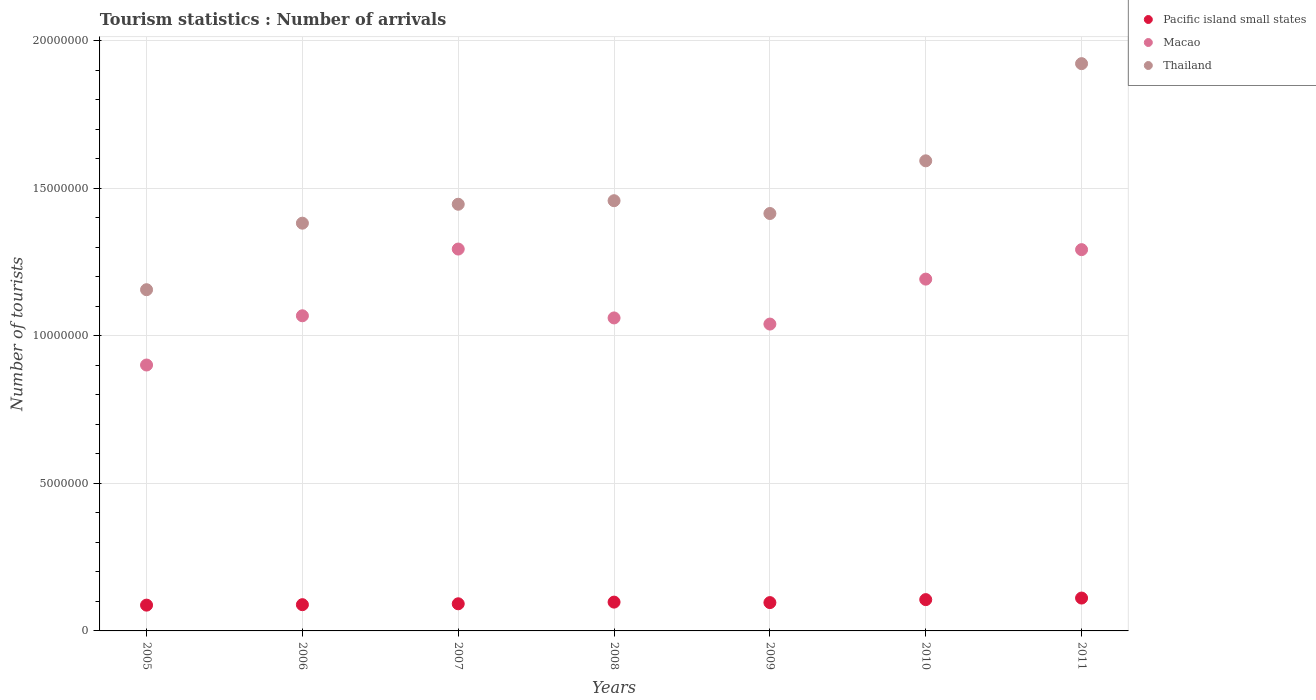Is the number of dotlines equal to the number of legend labels?
Your answer should be compact. Yes. What is the number of tourist arrivals in Macao in 2011?
Your answer should be very brief. 1.29e+07. Across all years, what is the maximum number of tourist arrivals in Pacific island small states?
Make the answer very short. 1.11e+06. Across all years, what is the minimum number of tourist arrivals in Macao?
Offer a terse response. 9.01e+06. In which year was the number of tourist arrivals in Thailand maximum?
Your response must be concise. 2011. What is the total number of tourist arrivals in Pacific island small states in the graph?
Provide a succinct answer. 6.79e+06. What is the difference between the number of tourist arrivals in Pacific island small states in 2005 and that in 2011?
Provide a short and direct response. -2.40e+05. What is the difference between the number of tourist arrivals in Thailand in 2009 and the number of tourist arrivals in Macao in 2010?
Provide a short and direct response. 2.22e+06. What is the average number of tourist arrivals in Thailand per year?
Provide a short and direct response. 1.48e+07. In the year 2010, what is the difference between the number of tourist arrivals in Pacific island small states and number of tourist arrivals in Macao?
Offer a very short reply. -1.09e+07. What is the ratio of the number of tourist arrivals in Pacific island small states in 2007 to that in 2009?
Ensure brevity in your answer.  0.96. Is the number of tourist arrivals in Pacific island small states in 2005 less than that in 2010?
Ensure brevity in your answer.  Yes. What is the difference between the highest and the lowest number of tourist arrivals in Macao?
Provide a short and direct response. 3.93e+06. In how many years, is the number of tourist arrivals in Macao greater than the average number of tourist arrivals in Macao taken over all years?
Give a very brief answer. 3. Is the number of tourist arrivals in Thailand strictly greater than the number of tourist arrivals in Macao over the years?
Your response must be concise. Yes. Is the number of tourist arrivals in Thailand strictly less than the number of tourist arrivals in Macao over the years?
Keep it short and to the point. No. What is the difference between two consecutive major ticks on the Y-axis?
Offer a terse response. 5.00e+06. Does the graph contain any zero values?
Your response must be concise. No. Where does the legend appear in the graph?
Keep it short and to the point. Top right. What is the title of the graph?
Your answer should be compact. Tourism statistics : Number of arrivals. What is the label or title of the X-axis?
Your answer should be very brief. Years. What is the label or title of the Y-axis?
Offer a terse response. Number of tourists. What is the Number of tourists in Pacific island small states in 2005?
Provide a short and direct response. 8.74e+05. What is the Number of tourists in Macao in 2005?
Provide a short and direct response. 9.01e+06. What is the Number of tourists in Thailand in 2005?
Offer a very short reply. 1.16e+07. What is the Number of tourists in Pacific island small states in 2006?
Your response must be concise. 8.90e+05. What is the Number of tourists in Macao in 2006?
Keep it short and to the point. 1.07e+07. What is the Number of tourists in Thailand in 2006?
Give a very brief answer. 1.38e+07. What is the Number of tourists in Pacific island small states in 2007?
Give a very brief answer. 9.20e+05. What is the Number of tourists in Macao in 2007?
Keep it short and to the point. 1.29e+07. What is the Number of tourists in Thailand in 2007?
Keep it short and to the point. 1.45e+07. What is the Number of tourists of Pacific island small states in 2008?
Make the answer very short. 9.77e+05. What is the Number of tourists of Macao in 2008?
Make the answer very short. 1.06e+07. What is the Number of tourists of Thailand in 2008?
Offer a terse response. 1.46e+07. What is the Number of tourists of Pacific island small states in 2009?
Give a very brief answer. 9.60e+05. What is the Number of tourists of Macao in 2009?
Offer a terse response. 1.04e+07. What is the Number of tourists of Thailand in 2009?
Offer a very short reply. 1.42e+07. What is the Number of tourists in Pacific island small states in 2010?
Offer a very short reply. 1.06e+06. What is the Number of tourists of Macao in 2010?
Offer a very short reply. 1.19e+07. What is the Number of tourists of Thailand in 2010?
Keep it short and to the point. 1.59e+07. What is the Number of tourists in Pacific island small states in 2011?
Provide a short and direct response. 1.11e+06. What is the Number of tourists of Macao in 2011?
Ensure brevity in your answer.  1.29e+07. What is the Number of tourists of Thailand in 2011?
Your response must be concise. 1.92e+07. Across all years, what is the maximum Number of tourists in Pacific island small states?
Offer a terse response. 1.11e+06. Across all years, what is the maximum Number of tourists of Macao?
Your response must be concise. 1.29e+07. Across all years, what is the maximum Number of tourists in Thailand?
Your response must be concise. 1.92e+07. Across all years, what is the minimum Number of tourists in Pacific island small states?
Make the answer very short. 8.74e+05. Across all years, what is the minimum Number of tourists in Macao?
Offer a very short reply. 9.01e+06. Across all years, what is the minimum Number of tourists of Thailand?
Give a very brief answer. 1.16e+07. What is the total Number of tourists of Pacific island small states in the graph?
Give a very brief answer. 6.79e+06. What is the total Number of tourists in Macao in the graph?
Keep it short and to the point. 7.85e+07. What is the total Number of tourists in Thailand in the graph?
Offer a terse response. 1.04e+08. What is the difference between the Number of tourists of Pacific island small states in 2005 and that in 2006?
Your answer should be compact. -1.53e+04. What is the difference between the Number of tourists in Macao in 2005 and that in 2006?
Your response must be concise. -1.67e+06. What is the difference between the Number of tourists of Thailand in 2005 and that in 2006?
Offer a terse response. -2.26e+06. What is the difference between the Number of tourists in Pacific island small states in 2005 and that in 2007?
Give a very brief answer. -4.56e+04. What is the difference between the Number of tourists in Macao in 2005 and that in 2007?
Your answer should be very brief. -3.93e+06. What is the difference between the Number of tourists in Thailand in 2005 and that in 2007?
Make the answer very short. -2.90e+06. What is the difference between the Number of tourists in Pacific island small states in 2005 and that in 2008?
Provide a succinct answer. -1.02e+05. What is the difference between the Number of tourists of Macao in 2005 and that in 2008?
Provide a short and direct response. -1.60e+06. What is the difference between the Number of tourists in Thailand in 2005 and that in 2008?
Give a very brief answer. -3.02e+06. What is the difference between the Number of tourists in Pacific island small states in 2005 and that in 2009?
Make the answer very short. -8.60e+04. What is the difference between the Number of tourists in Macao in 2005 and that in 2009?
Keep it short and to the point. -1.39e+06. What is the difference between the Number of tourists in Thailand in 2005 and that in 2009?
Your answer should be compact. -2.58e+06. What is the difference between the Number of tourists in Pacific island small states in 2005 and that in 2010?
Ensure brevity in your answer.  -1.86e+05. What is the difference between the Number of tourists of Macao in 2005 and that in 2010?
Provide a succinct answer. -2.91e+06. What is the difference between the Number of tourists of Thailand in 2005 and that in 2010?
Give a very brief answer. -4.37e+06. What is the difference between the Number of tourists in Pacific island small states in 2005 and that in 2011?
Your response must be concise. -2.40e+05. What is the difference between the Number of tourists in Macao in 2005 and that in 2011?
Make the answer very short. -3.91e+06. What is the difference between the Number of tourists in Thailand in 2005 and that in 2011?
Make the answer very short. -7.66e+06. What is the difference between the Number of tourists in Pacific island small states in 2006 and that in 2007?
Keep it short and to the point. -3.03e+04. What is the difference between the Number of tourists in Macao in 2006 and that in 2007?
Ensure brevity in your answer.  -2.26e+06. What is the difference between the Number of tourists of Thailand in 2006 and that in 2007?
Make the answer very short. -6.42e+05. What is the difference between the Number of tourists in Pacific island small states in 2006 and that in 2008?
Provide a short and direct response. -8.71e+04. What is the difference between the Number of tourists in Macao in 2006 and that in 2008?
Provide a short and direct response. 7.30e+04. What is the difference between the Number of tourists in Thailand in 2006 and that in 2008?
Keep it short and to the point. -7.62e+05. What is the difference between the Number of tourists in Pacific island small states in 2006 and that in 2009?
Ensure brevity in your answer.  -7.07e+04. What is the difference between the Number of tourists of Macao in 2006 and that in 2009?
Offer a very short reply. 2.81e+05. What is the difference between the Number of tourists in Thailand in 2006 and that in 2009?
Offer a very short reply. -3.28e+05. What is the difference between the Number of tourists in Pacific island small states in 2006 and that in 2010?
Your answer should be very brief. -1.71e+05. What is the difference between the Number of tourists of Macao in 2006 and that in 2010?
Your answer should be compact. -1.24e+06. What is the difference between the Number of tourists in Thailand in 2006 and that in 2010?
Your answer should be very brief. -2.11e+06. What is the difference between the Number of tourists of Pacific island small states in 2006 and that in 2011?
Offer a very short reply. -2.24e+05. What is the difference between the Number of tourists of Macao in 2006 and that in 2011?
Your answer should be very brief. -2.24e+06. What is the difference between the Number of tourists of Thailand in 2006 and that in 2011?
Provide a succinct answer. -5.41e+06. What is the difference between the Number of tourists of Pacific island small states in 2007 and that in 2008?
Your answer should be very brief. -5.68e+04. What is the difference between the Number of tourists in Macao in 2007 and that in 2008?
Offer a terse response. 2.34e+06. What is the difference between the Number of tourists in Pacific island small states in 2007 and that in 2009?
Give a very brief answer. -4.04e+04. What is the difference between the Number of tourists in Macao in 2007 and that in 2009?
Ensure brevity in your answer.  2.54e+06. What is the difference between the Number of tourists in Thailand in 2007 and that in 2009?
Your response must be concise. 3.14e+05. What is the difference between the Number of tourists of Pacific island small states in 2007 and that in 2010?
Ensure brevity in your answer.  -1.41e+05. What is the difference between the Number of tourists in Macao in 2007 and that in 2010?
Ensure brevity in your answer.  1.02e+06. What is the difference between the Number of tourists of Thailand in 2007 and that in 2010?
Offer a terse response. -1.47e+06. What is the difference between the Number of tourists of Pacific island small states in 2007 and that in 2011?
Your answer should be very brief. -1.94e+05. What is the difference between the Number of tourists in Macao in 2007 and that in 2011?
Ensure brevity in your answer.  2.00e+04. What is the difference between the Number of tourists in Thailand in 2007 and that in 2011?
Provide a short and direct response. -4.77e+06. What is the difference between the Number of tourists of Pacific island small states in 2008 and that in 2009?
Offer a very short reply. 1.64e+04. What is the difference between the Number of tourists in Macao in 2008 and that in 2009?
Offer a terse response. 2.08e+05. What is the difference between the Number of tourists of Thailand in 2008 and that in 2009?
Make the answer very short. 4.34e+05. What is the difference between the Number of tourists of Pacific island small states in 2008 and that in 2010?
Your response must be concise. -8.39e+04. What is the difference between the Number of tourists of Macao in 2008 and that in 2010?
Provide a short and direct response. -1.32e+06. What is the difference between the Number of tourists in Thailand in 2008 and that in 2010?
Ensure brevity in your answer.  -1.35e+06. What is the difference between the Number of tourists in Pacific island small states in 2008 and that in 2011?
Give a very brief answer. -1.37e+05. What is the difference between the Number of tourists of Macao in 2008 and that in 2011?
Give a very brief answer. -2.32e+06. What is the difference between the Number of tourists in Thailand in 2008 and that in 2011?
Offer a terse response. -4.65e+06. What is the difference between the Number of tourists in Pacific island small states in 2009 and that in 2010?
Your response must be concise. -1.00e+05. What is the difference between the Number of tourists of Macao in 2009 and that in 2010?
Keep it short and to the point. -1.52e+06. What is the difference between the Number of tourists of Thailand in 2009 and that in 2010?
Your response must be concise. -1.79e+06. What is the difference between the Number of tourists of Pacific island small states in 2009 and that in 2011?
Offer a terse response. -1.54e+05. What is the difference between the Number of tourists of Macao in 2009 and that in 2011?
Offer a very short reply. -2.52e+06. What is the difference between the Number of tourists of Thailand in 2009 and that in 2011?
Offer a very short reply. -5.08e+06. What is the difference between the Number of tourists of Pacific island small states in 2010 and that in 2011?
Provide a succinct answer. -5.35e+04. What is the difference between the Number of tourists of Macao in 2010 and that in 2011?
Make the answer very short. -9.99e+05. What is the difference between the Number of tourists of Thailand in 2010 and that in 2011?
Offer a terse response. -3.29e+06. What is the difference between the Number of tourists of Pacific island small states in 2005 and the Number of tourists of Macao in 2006?
Your response must be concise. -9.81e+06. What is the difference between the Number of tourists of Pacific island small states in 2005 and the Number of tourists of Thailand in 2006?
Offer a terse response. -1.29e+07. What is the difference between the Number of tourists in Macao in 2005 and the Number of tourists in Thailand in 2006?
Your answer should be very brief. -4.81e+06. What is the difference between the Number of tourists in Pacific island small states in 2005 and the Number of tourists in Macao in 2007?
Provide a short and direct response. -1.21e+07. What is the difference between the Number of tourists in Pacific island small states in 2005 and the Number of tourists in Thailand in 2007?
Your response must be concise. -1.36e+07. What is the difference between the Number of tourists in Macao in 2005 and the Number of tourists in Thailand in 2007?
Keep it short and to the point. -5.45e+06. What is the difference between the Number of tourists of Pacific island small states in 2005 and the Number of tourists of Macao in 2008?
Keep it short and to the point. -9.74e+06. What is the difference between the Number of tourists in Pacific island small states in 2005 and the Number of tourists in Thailand in 2008?
Give a very brief answer. -1.37e+07. What is the difference between the Number of tourists of Macao in 2005 and the Number of tourists of Thailand in 2008?
Offer a terse response. -5.57e+06. What is the difference between the Number of tourists of Pacific island small states in 2005 and the Number of tourists of Macao in 2009?
Your response must be concise. -9.53e+06. What is the difference between the Number of tourists in Pacific island small states in 2005 and the Number of tourists in Thailand in 2009?
Your answer should be very brief. -1.33e+07. What is the difference between the Number of tourists of Macao in 2005 and the Number of tourists of Thailand in 2009?
Give a very brief answer. -5.14e+06. What is the difference between the Number of tourists of Pacific island small states in 2005 and the Number of tourists of Macao in 2010?
Give a very brief answer. -1.11e+07. What is the difference between the Number of tourists of Pacific island small states in 2005 and the Number of tourists of Thailand in 2010?
Your response must be concise. -1.51e+07. What is the difference between the Number of tourists of Macao in 2005 and the Number of tourists of Thailand in 2010?
Keep it short and to the point. -6.92e+06. What is the difference between the Number of tourists in Pacific island small states in 2005 and the Number of tourists in Macao in 2011?
Provide a short and direct response. -1.21e+07. What is the difference between the Number of tourists in Pacific island small states in 2005 and the Number of tourists in Thailand in 2011?
Your answer should be compact. -1.84e+07. What is the difference between the Number of tourists of Macao in 2005 and the Number of tourists of Thailand in 2011?
Give a very brief answer. -1.02e+07. What is the difference between the Number of tourists of Pacific island small states in 2006 and the Number of tourists of Macao in 2007?
Make the answer very short. -1.21e+07. What is the difference between the Number of tourists of Pacific island small states in 2006 and the Number of tourists of Thailand in 2007?
Ensure brevity in your answer.  -1.36e+07. What is the difference between the Number of tourists in Macao in 2006 and the Number of tourists in Thailand in 2007?
Your answer should be very brief. -3.78e+06. What is the difference between the Number of tourists of Pacific island small states in 2006 and the Number of tourists of Macao in 2008?
Offer a terse response. -9.72e+06. What is the difference between the Number of tourists in Pacific island small states in 2006 and the Number of tourists in Thailand in 2008?
Give a very brief answer. -1.37e+07. What is the difference between the Number of tourists of Macao in 2006 and the Number of tourists of Thailand in 2008?
Offer a very short reply. -3.90e+06. What is the difference between the Number of tourists of Pacific island small states in 2006 and the Number of tourists of Macao in 2009?
Provide a succinct answer. -9.51e+06. What is the difference between the Number of tourists of Pacific island small states in 2006 and the Number of tourists of Thailand in 2009?
Make the answer very short. -1.33e+07. What is the difference between the Number of tourists in Macao in 2006 and the Number of tourists in Thailand in 2009?
Make the answer very short. -3.47e+06. What is the difference between the Number of tourists in Pacific island small states in 2006 and the Number of tourists in Macao in 2010?
Offer a terse response. -1.10e+07. What is the difference between the Number of tourists of Pacific island small states in 2006 and the Number of tourists of Thailand in 2010?
Provide a short and direct response. -1.50e+07. What is the difference between the Number of tourists of Macao in 2006 and the Number of tourists of Thailand in 2010?
Your answer should be very brief. -5.25e+06. What is the difference between the Number of tourists in Pacific island small states in 2006 and the Number of tourists in Macao in 2011?
Your answer should be compact. -1.20e+07. What is the difference between the Number of tourists of Pacific island small states in 2006 and the Number of tourists of Thailand in 2011?
Provide a short and direct response. -1.83e+07. What is the difference between the Number of tourists of Macao in 2006 and the Number of tourists of Thailand in 2011?
Your answer should be compact. -8.55e+06. What is the difference between the Number of tourists in Pacific island small states in 2007 and the Number of tourists in Macao in 2008?
Keep it short and to the point. -9.69e+06. What is the difference between the Number of tourists of Pacific island small states in 2007 and the Number of tourists of Thailand in 2008?
Offer a terse response. -1.37e+07. What is the difference between the Number of tourists of Macao in 2007 and the Number of tourists of Thailand in 2008?
Your answer should be compact. -1.64e+06. What is the difference between the Number of tourists in Pacific island small states in 2007 and the Number of tourists in Macao in 2009?
Offer a very short reply. -9.48e+06. What is the difference between the Number of tourists of Pacific island small states in 2007 and the Number of tourists of Thailand in 2009?
Make the answer very short. -1.32e+07. What is the difference between the Number of tourists of Macao in 2007 and the Number of tourists of Thailand in 2009?
Offer a terse response. -1.20e+06. What is the difference between the Number of tourists in Pacific island small states in 2007 and the Number of tourists in Macao in 2010?
Your response must be concise. -1.10e+07. What is the difference between the Number of tourists of Pacific island small states in 2007 and the Number of tourists of Thailand in 2010?
Give a very brief answer. -1.50e+07. What is the difference between the Number of tourists in Macao in 2007 and the Number of tourists in Thailand in 2010?
Provide a short and direct response. -2.99e+06. What is the difference between the Number of tourists in Pacific island small states in 2007 and the Number of tourists in Macao in 2011?
Make the answer very short. -1.20e+07. What is the difference between the Number of tourists of Pacific island small states in 2007 and the Number of tourists of Thailand in 2011?
Give a very brief answer. -1.83e+07. What is the difference between the Number of tourists of Macao in 2007 and the Number of tourists of Thailand in 2011?
Provide a succinct answer. -6.28e+06. What is the difference between the Number of tourists in Pacific island small states in 2008 and the Number of tourists in Macao in 2009?
Make the answer very short. -9.43e+06. What is the difference between the Number of tourists of Pacific island small states in 2008 and the Number of tourists of Thailand in 2009?
Your response must be concise. -1.32e+07. What is the difference between the Number of tourists of Macao in 2008 and the Number of tourists of Thailand in 2009?
Make the answer very short. -3.54e+06. What is the difference between the Number of tourists of Pacific island small states in 2008 and the Number of tourists of Macao in 2010?
Your answer should be compact. -1.09e+07. What is the difference between the Number of tourists in Pacific island small states in 2008 and the Number of tourists in Thailand in 2010?
Offer a terse response. -1.50e+07. What is the difference between the Number of tourists in Macao in 2008 and the Number of tourists in Thailand in 2010?
Make the answer very short. -5.33e+06. What is the difference between the Number of tourists in Pacific island small states in 2008 and the Number of tourists in Macao in 2011?
Give a very brief answer. -1.19e+07. What is the difference between the Number of tourists in Pacific island small states in 2008 and the Number of tourists in Thailand in 2011?
Keep it short and to the point. -1.83e+07. What is the difference between the Number of tourists of Macao in 2008 and the Number of tourists of Thailand in 2011?
Your response must be concise. -8.62e+06. What is the difference between the Number of tourists in Pacific island small states in 2009 and the Number of tourists in Macao in 2010?
Keep it short and to the point. -1.10e+07. What is the difference between the Number of tourists in Pacific island small states in 2009 and the Number of tourists in Thailand in 2010?
Your response must be concise. -1.50e+07. What is the difference between the Number of tourists of Macao in 2009 and the Number of tourists of Thailand in 2010?
Provide a succinct answer. -5.53e+06. What is the difference between the Number of tourists of Pacific island small states in 2009 and the Number of tourists of Macao in 2011?
Keep it short and to the point. -1.20e+07. What is the difference between the Number of tourists in Pacific island small states in 2009 and the Number of tourists in Thailand in 2011?
Offer a terse response. -1.83e+07. What is the difference between the Number of tourists in Macao in 2009 and the Number of tourists in Thailand in 2011?
Provide a short and direct response. -8.83e+06. What is the difference between the Number of tourists in Pacific island small states in 2010 and the Number of tourists in Macao in 2011?
Your response must be concise. -1.19e+07. What is the difference between the Number of tourists in Pacific island small states in 2010 and the Number of tourists in Thailand in 2011?
Give a very brief answer. -1.82e+07. What is the difference between the Number of tourists in Macao in 2010 and the Number of tourists in Thailand in 2011?
Provide a succinct answer. -7.30e+06. What is the average Number of tourists in Pacific island small states per year?
Provide a succinct answer. 9.71e+05. What is the average Number of tourists of Macao per year?
Ensure brevity in your answer.  1.12e+07. What is the average Number of tourists in Thailand per year?
Offer a terse response. 1.48e+07. In the year 2005, what is the difference between the Number of tourists of Pacific island small states and Number of tourists of Macao?
Provide a succinct answer. -8.14e+06. In the year 2005, what is the difference between the Number of tourists in Pacific island small states and Number of tourists in Thailand?
Give a very brief answer. -1.07e+07. In the year 2005, what is the difference between the Number of tourists in Macao and Number of tourists in Thailand?
Offer a terse response. -2.55e+06. In the year 2006, what is the difference between the Number of tourists in Pacific island small states and Number of tourists in Macao?
Ensure brevity in your answer.  -9.79e+06. In the year 2006, what is the difference between the Number of tourists of Pacific island small states and Number of tourists of Thailand?
Make the answer very short. -1.29e+07. In the year 2006, what is the difference between the Number of tourists of Macao and Number of tourists of Thailand?
Ensure brevity in your answer.  -3.14e+06. In the year 2007, what is the difference between the Number of tourists in Pacific island small states and Number of tourists in Macao?
Offer a very short reply. -1.20e+07. In the year 2007, what is the difference between the Number of tourists in Pacific island small states and Number of tourists in Thailand?
Your answer should be compact. -1.35e+07. In the year 2007, what is the difference between the Number of tourists in Macao and Number of tourists in Thailand?
Make the answer very short. -1.52e+06. In the year 2008, what is the difference between the Number of tourists of Pacific island small states and Number of tourists of Macao?
Your answer should be very brief. -9.63e+06. In the year 2008, what is the difference between the Number of tourists of Pacific island small states and Number of tourists of Thailand?
Give a very brief answer. -1.36e+07. In the year 2008, what is the difference between the Number of tourists of Macao and Number of tourists of Thailand?
Ensure brevity in your answer.  -3.97e+06. In the year 2009, what is the difference between the Number of tourists of Pacific island small states and Number of tourists of Macao?
Make the answer very short. -9.44e+06. In the year 2009, what is the difference between the Number of tourists of Pacific island small states and Number of tourists of Thailand?
Offer a terse response. -1.32e+07. In the year 2009, what is the difference between the Number of tourists of Macao and Number of tourists of Thailand?
Offer a very short reply. -3.75e+06. In the year 2010, what is the difference between the Number of tourists in Pacific island small states and Number of tourists in Macao?
Provide a succinct answer. -1.09e+07. In the year 2010, what is the difference between the Number of tourists in Pacific island small states and Number of tourists in Thailand?
Give a very brief answer. -1.49e+07. In the year 2010, what is the difference between the Number of tourists of Macao and Number of tourists of Thailand?
Offer a very short reply. -4.01e+06. In the year 2011, what is the difference between the Number of tourists in Pacific island small states and Number of tourists in Macao?
Your response must be concise. -1.18e+07. In the year 2011, what is the difference between the Number of tourists of Pacific island small states and Number of tourists of Thailand?
Keep it short and to the point. -1.81e+07. In the year 2011, what is the difference between the Number of tourists of Macao and Number of tourists of Thailand?
Give a very brief answer. -6.30e+06. What is the ratio of the Number of tourists of Pacific island small states in 2005 to that in 2006?
Ensure brevity in your answer.  0.98. What is the ratio of the Number of tourists in Macao in 2005 to that in 2006?
Provide a short and direct response. 0.84. What is the ratio of the Number of tourists of Thailand in 2005 to that in 2006?
Your answer should be compact. 0.84. What is the ratio of the Number of tourists of Pacific island small states in 2005 to that in 2007?
Make the answer very short. 0.95. What is the ratio of the Number of tourists in Macao in 2005 to that in 2007?
Provide a short and direct response. 0.7. What is the ratio of the Number of tourists in Thailand in 2005 to that in 2007?
Provide a short and direct response. 0.8. What is the ratio of the Number of tourists of Pacific island small states in 2005 to that in 2008?
Make the answer very short. 0.9. What is the ratio of the Number of tourists in Macao in 2005 to that in 2008?
Offer a very short reply. 0.85. What is the ratio of the Number of tourists of Thailand in 2005 to that in 2008?
Provide a succinct answer. 0.79. What is the ratio of the Number of tourists in Pacific island small states in 2005 to that in 2009?
Offer a very short reply. 0.91. What is the ratio of the Number of tourists in Macao in 2005 to that in 2009?
Your answer should be compact. 0.87. What is the ratio of the Number of tourists of Thailand in 2005 to that in 2009?
Provide a succinct answer. 0.82. What is the ratio of the Number of tourists of Pacific island small states in 2005 to that in 2010?
Give a very brief answer. 0.82. What is the ratio of the Number of tourists in Macao in 2005 to that in 2010?
Ensure brevity in your answer.  0.76. What is the ratio of the Number of tourists in Thailand in 2005 to that in 2010?
Offer a very short reply. 0.73. What is the ratio of the Number of tourists in Pacific island small states in 2005 to that in 2011?
Offer a terse response. 0.78. What is the ratio of the Number of tourists of Macao in 2005 to that in 2011?
Your answer should be compact. 0.7. What is the ratio of the Number of tourists of Thailand in 2005 to that in 2011?
Make the answer very short. 0.6. What is the ratio of the Number of tourists in Pacific island small states in 2006 to that in 2007?
Provide a short and direct response. 0.97. What is the ratio of the Number of tourists in Macao in 2006 to that in 2007?
Offer a very short reply. 0.83. What is the ratio of the Number of tourists of Thailand in 2006 to that in 2007?
Offer a terse response. 0.96. What is the ratio of the Number of tourists of Pacific island small states in 2006 to that in 2008?
Keep it short and to the point. 0.91. What is the ratio of the Number of tourists of Macao in 2006 to that in 2008?
Your response must be concise. 1.01. What is the ratio of the Number of tourists in Thailand in 2006 to that in 2008?
Your answer should be very brief. 0.95. What is the ratio of the Number of tourists of Pacific island small states in 2006 to that in 2009?
Offer a terse response. 0.93. What is the ratio of the Number of tourists of Macao in 2006 to that in 2009?
Make the answer very short. 1.03. What is the ratio of the Number of tourists of Thailand in 2006 to that in 2009?
Ensure brevity in your answer.  0.98. What is the ratio of the Number of tourists of Pacific island small states in 2006 to that in 2010?
Provide a succinct answer. 0.84. What is the ratio of the Number of tourists of Macao in 2006 to that in 2010?
Your answer should be very brief. 0.9. What is the ratio of the Number of tourists of Thailand in 2006 to that in 2010?
Provide a succinct answer. 0.87. What is the ratio of the Number of tourists of Pacific island small states in 2006 to that in 2011?
Your answer should be very brief. 0.8. What is the ratio of the Number of tourists of Macao in 2006 to that in 2011?
Give a very brief answer. 0.83. What is the ratio of the Number of tourists in Thailand in 2006 to that in 2011?
Keep it short and to the point. 0.72. What is the ratio of the Number of tourists of Pacific island small states in 2007 to that in 2008?
Give a very brief answer. 0.94. What is the ratio of the Number of tourists of Macao in 2007 to that in 2008?
Your answer should be very brief. 1.22. What is the ratio of the Number of tourists of Thailand in 2007 to that in 2008?
Provide a short and direct response. 0.99. What is the ratio of the Number of tourists of Pacific island small states in 2007 to that in 2009?
Your answer should be compact. 0.96. What is the ratio of the Number of tourists in Macao in 2007 to that in 2009?
Your answer should be very brief. 1.24. What is the ratio of the Number of tourists of Thailand in 2007 to that in 2009?
Ensure brevity in your answer.  1.02. What is the ratio of the Number of tourists of Pacific island small states in 2007 to that in 2010?
Provide a short and direct response. 0.87. What is the ratio of the Number of tourists of Macao in 2007 to that in 2010?
Give a very brief answer. 1.09. What is the ratio of the Number of tourists of Thailand in 2007 to that in 2010?
Offer a very short reply. 0.91. What is the ratio of the Number of tourists in Pacific island small states in 2007 to that in 2011?
Keep it short and to the point. 0.83. What is the ratio of the Number of tourists in Macao in 2007 to that in 2011?
Give a very brief answer. 1. What is the ratio of the Number of tourists of Thailand in 2007 to that in 2011?
Make the answer very short. 0.75. What is the ratio of the Number of tourists in Pacific island small states in 2008 to that in 2009?
Provide a short and direct response. 1.02. What is the ratio of the Number of tourists of Thailand in 2008 to that in 2009?
Give a very brief answer. 1.03. What is the ratio of the Number of tourists of Pacific island small states in 2008 to that in 2010?
Your answer should be compact. 0.92. What is the ratio of the Number of tourists in Macao in 2008 to that in 2010?
Your answer should be compact. 0.89. What is the ratio of the Number of tourists in Thailand in 2008 to that in 2010?
Your answer should be very brief. 0.92. What is the ratio of the Number of tourists of Pacific island small states in 2008 to that in 2011?
Provide a succinct answer. 0.88. What is the ratio of the Number of tourists of Macao in 2008 to that in 2011?
Offer a terse response. 0.82. What is the ratio of the Number of tourists of Thailand in 2008 to that in 2011?
Provide a short and direct response. 0.76. What is the ratio of the Number of tourists of Pacific island small states in 2009 to that in 2010?
Offer a terse response. 0.91. What is the ratio of the Number of tourists of Macao in 2009 to that in 2010?
Provide a short and direct response. 0.87. What is the ratio of the Number of tourists in Thailand in 2009 to that in 2010?
Offer a very short reply. 0.89. What is the ratio of the Number of tourists of Pacific island small states in 2009 to that in 2011?
Give a very brief answer. 0.86. What is the ratio of the Number of tourists in Macao in 2009 to that in 2011?
Offer a terse response. 0.8. What is the ratio of the Number of tourists in Thailand in 2009 to that in 2011?
Your response must be concise. 0.74. What is the ratio of the Number of tourists in Macao in 2010 to that in 2011?
Provide a succinct answer. 0.92. What is the ratio of the Number of tourists of Thailand in 2010 to that in 2011?
Keep it short and to the point. 0.83. What is the difference between the highest and the second highest Number of tourists in Pacific island small states?
Your response must be concise. 5.35e+04. What is the difference between the highest and the second highest Number of tourists of Macao?
Provide a succinct answer. 2.00e+04. What is the difference between the highest and the second highest Number of tourists of Thailand?
Your answer should be compact. 3.29e+06. What is the difference between the highest and the lowest Number of tourists of Pacific island small states?
Ensure brevity in your answer.  2.40e+05. What is the difference between the highest and the lowest Number of tourists of Macao?
Make the answer very short. 3.93e+06. What is the difference between the highest and the lowest Number of tourists in Thailand?
Your answer should be very brief. 7.66e+06. 